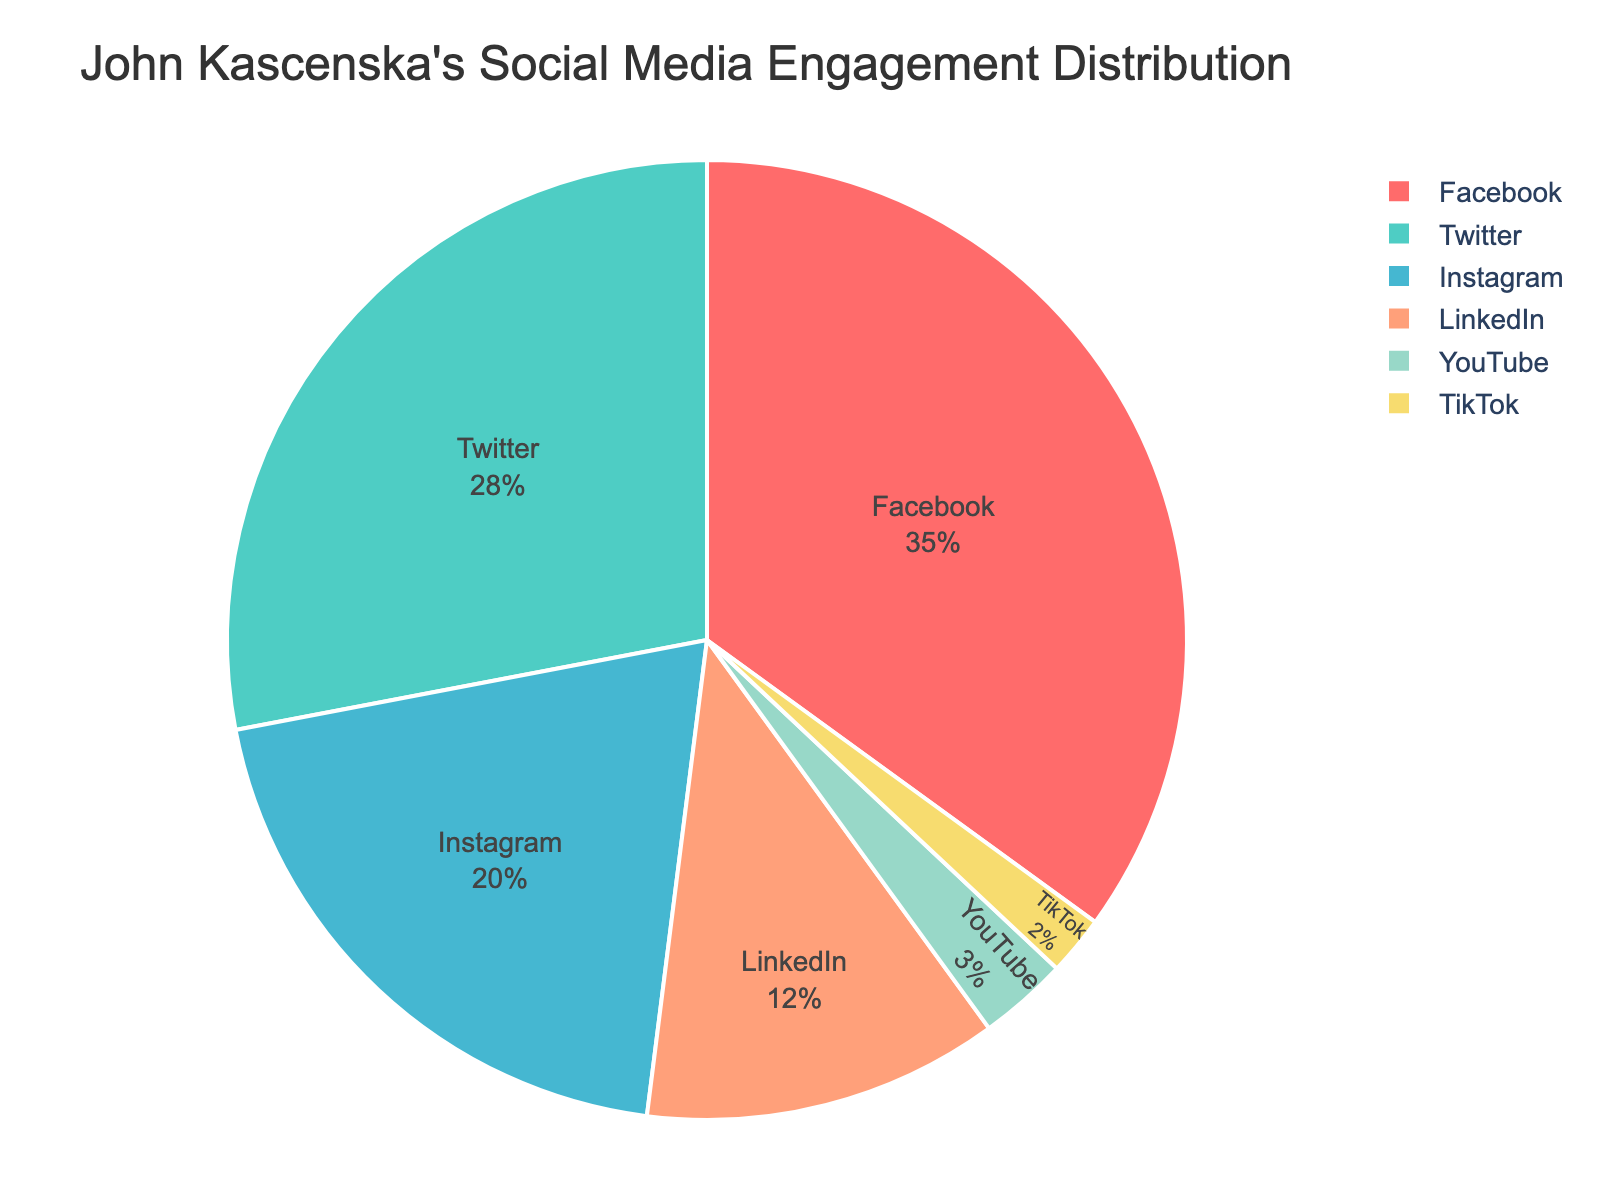Which platform has the highest percentage of engagement? The segment with the highest percentage is identified by observing the largest piece of the pie chart. That piece is labeled 'Facebook' with 35%.
Answer: Facebook Which platform has the lowest engagement percentage? Look for the smallest slice of the pie chart, which is labeled 'TikTok' with 2%.
Answer: TikTok What is the combined engagement percentage for Instagram and LinkedIn? Add the percentages for Instagram (20%) and LinkedIn (12%). 20 + 12 = 32
Answer: 32 How much greater is Facebook's percentage compared to YouTube's? Subtract YouTube's percentage (3%) from Facebook's percentage (35%). 35 - 3 = 32
Answer: 32 Which platform has a slightly higher engagement percentage, Twitter or Instagram? Compare the percentages for Twitter (28%) and Instagram (20%). Twitter is higher.
Answer: Twitter What is the combined engagement percentage for all platforms except Facebook? Add the percentages for Twitter (28%), Instagram (20%), LinkedIn (12%), YouTube (3%), and TikTok (2%). 28 + 20 + 12 + 3 + 2 = 65
Answer: 65 Is LinkedIn's engagement percentage closer to Twitter's or Instagram's? Calculate the absolute differences: LinkedIn (12%) to Twitter (28%) is 16, LinkedIn (12%) to Instagram (20%) is 8. 12 is closer to 20.
Answer: Instagram What percentage of the engagement is on platforms other than Facebook and Twitter? Sum the percentages for Instagram (20%), LinkedIn (12%), YouTube (3%), and TikTok (2%). 20 + 12 + 3 + 2 = 37
Answer: 37 By how much does Twitter's engagement exceed that of LinkedIn? Subtract LinkedIn's percentage (12%) from Twitter's percentage (28%). 28 - 12 = 16
Answer: 16 